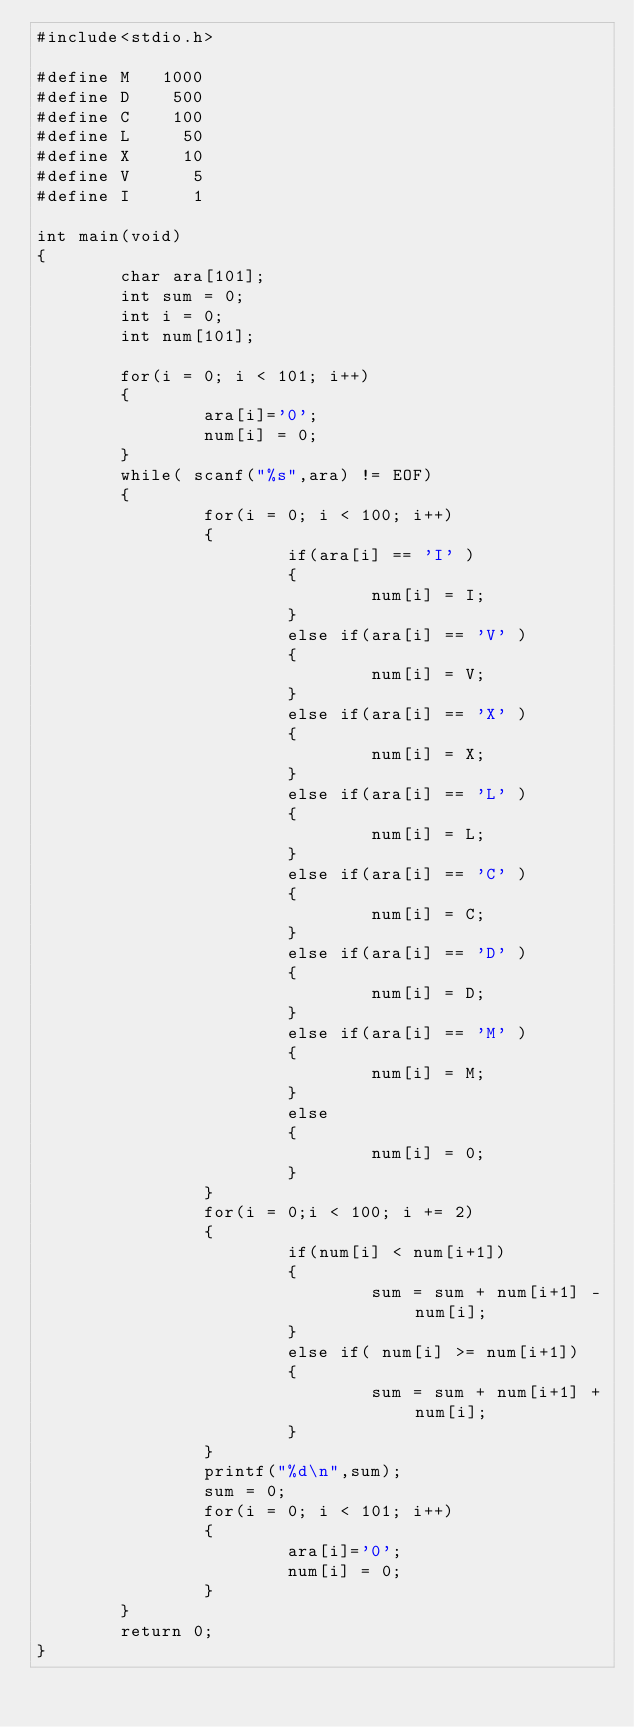Convert code to text. <code><loc_0><loc_0><loc_500><loc_500><_C_>#include<stdio.h>

#define M   1000
#define D    500
#define C    100
#define L     50
#define X     10
#define V      5
#define I      1

int main(void)
{
        char ara[101];
        int sum = 0;
        int i = 0;
        int num[101];

        for(i = 0; i < 101; i++)
        {
                ara[i]='0';
                num[i] = 0;
        }
        while( scanf("%s",ara) != EOF)
        {
                for(i = 0; i < 100; i++)
                {
                        if(ara[i] == 'I' )
                        {
                                num[i] = I;
                        }
                        else if(ara[i] == 'V' )
                        {
                                num[i] = V;
                        }
                        else if(ara[i] == 'X' )
                        {
                                num[i] = X;
                        }
                        else if(ara[i] == 'L' )
                        {
                                num[i] = L;
                        }
                        else if(ara[i] == 'C' )
                        {
                                num[i] = C;
                        }
                        else if(ara[i] == 'D' )
                        {
                                num[i] = D;
                        }
                        else if(ara[i] == 'M' )
                        {
                                num[i] = M;
                        }
                        else
                        {
                                num[i] = 0;
                        }
                }
                for(i = 0;i < 100; i += 2)
                {
                        if(num[i] < num[i+1])
                        {
                                sum = sum + num[i+1] - num[i];
                        }
                        else if( num[i] >= num[i+1])
                        {
                                sum = sum + num[i+1] + num[i];
                        }
                }
                printf("%d\n",sum);
                sum = 0;
                for(i = 0; i < 101; i++)
                {
                        ara[i]='0';
                        num[i] = 0;
                }
        }
        return 0;
}</code> 